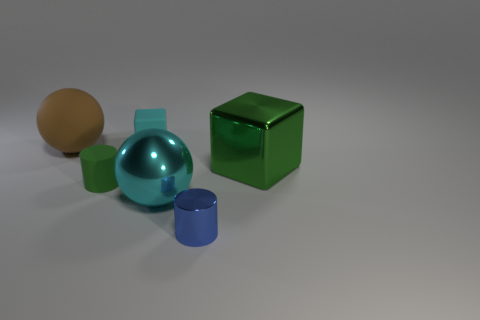Add 3 large green shiny objects. How many objects exist? 9 Subtract all balls. How many objects are left? 4 Subtract 0 purple blocks. How many objects are left? 6 Subtract all brown rubber spheres. Subtract all purple things. How many objects are left? 5 Add 1 small cyan things. How many small cyan things are left? 2 Add 6 large brown matte things. How many large brown matte things exist? 7 